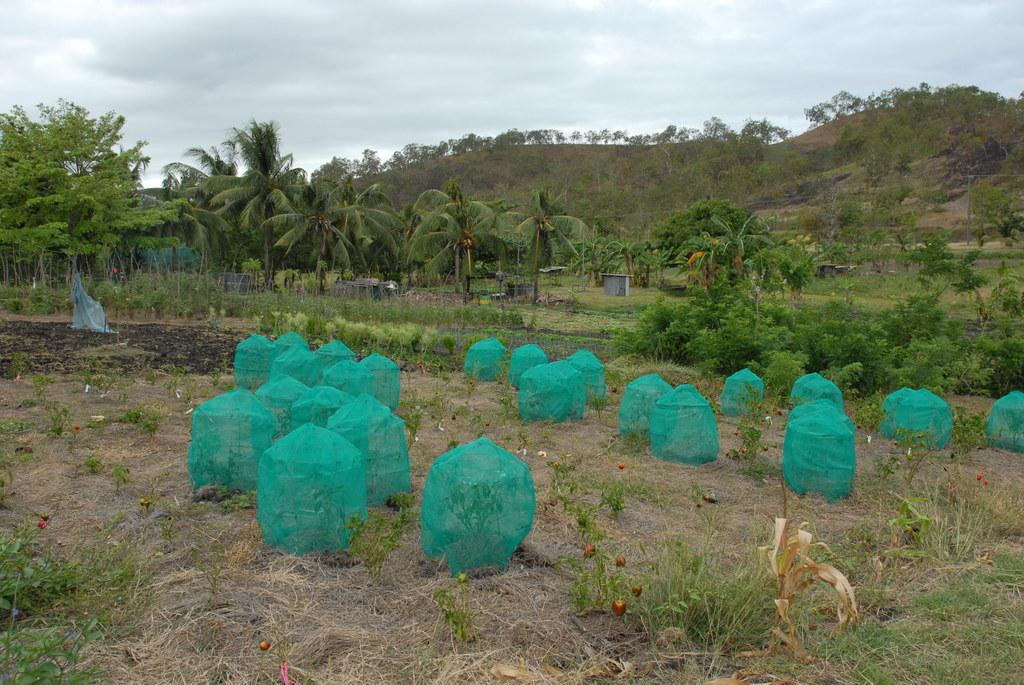What type of view is shown in the image? The image has an outside view. What can be seen covered with nets in the image? There are plants covered with nets in the image. What type of vegetation is present in the image? There are trees in the image. What geographical feature can be seen in the image? There is a hill in the image. What is visible at the top of the image? The sky is visible at the top of the image. What type of wine is being served by the giants in the image? There are no giants or wine present in the image. 